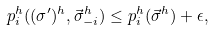Convert formula to latex. <formula><loc_0><loc_0><loc_500><loc_500>p _ { i } ^ { h } ( ( \sigma ^ { \prime } ) ^ { h } , \vec { \sigma } ^ { h } _ { - i } ) \leq p _ { i } ^ { h } ( \vec { \sigma } ^ { h } ) + \epsilon ,</formula> 